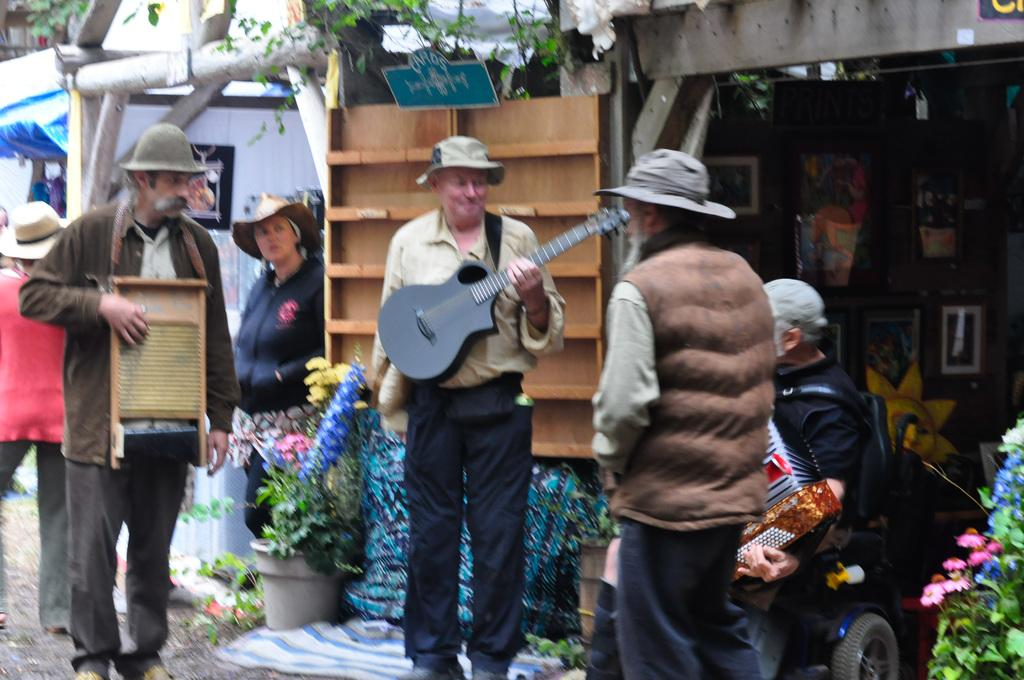What are the people in the image doing? The people in the image are standing on a road. Are any of the people holding anything specific? Yes, some of the people are holding musical instruments. What can be seen in the background of the image? There are shops in the background of the image. What items are present in the shops? Flower vases are present in the shops. How many minutes does it take for the sky to change color in the image? The image does not show the sky changing color, so it is not possible to determine how many minutes it takes. 